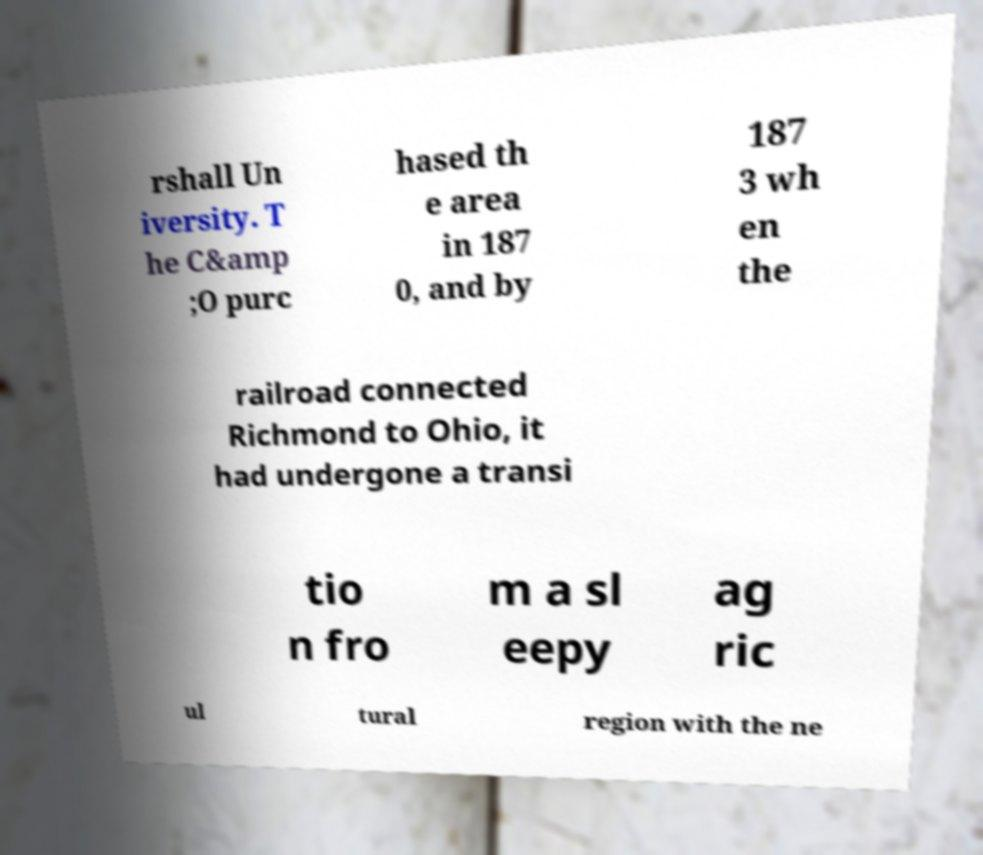Please read and relay the text visible in this image. What does it say? rshall Un iversity. T he C&amp ;O purc hased th e area in 187 0, and by 187 3 wh en the railroad connected Richmond to Ohio, it had undergone a transi tio n fro m a sl eepy ag ric ul tural region with the ne 